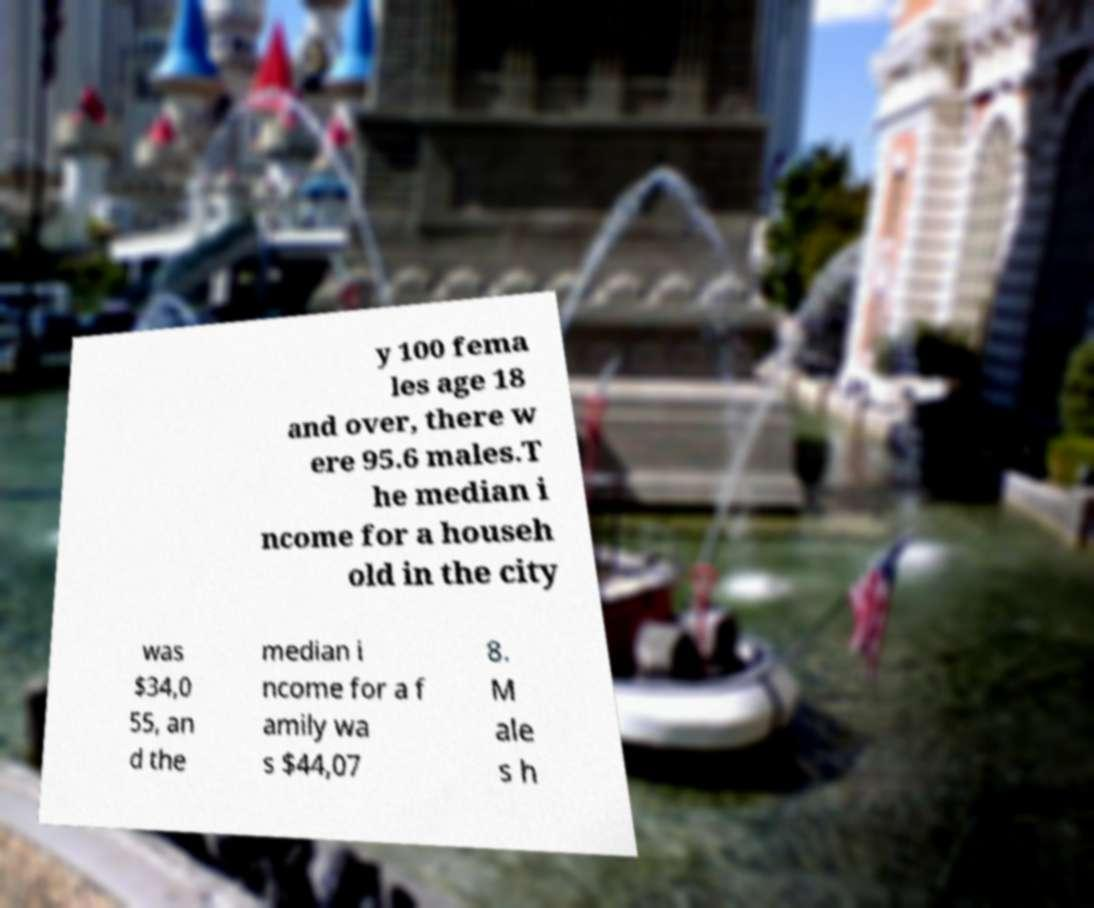Could you assist in decoding the text presented in this image and type it out clearly? y 100 fema les age 18 and over, there w ere 95.6 males.T he median i ncome for a househ old in the city was $34,0 55, an d the median i ncome for a f amily wa s $44,07 8. M ale s h 